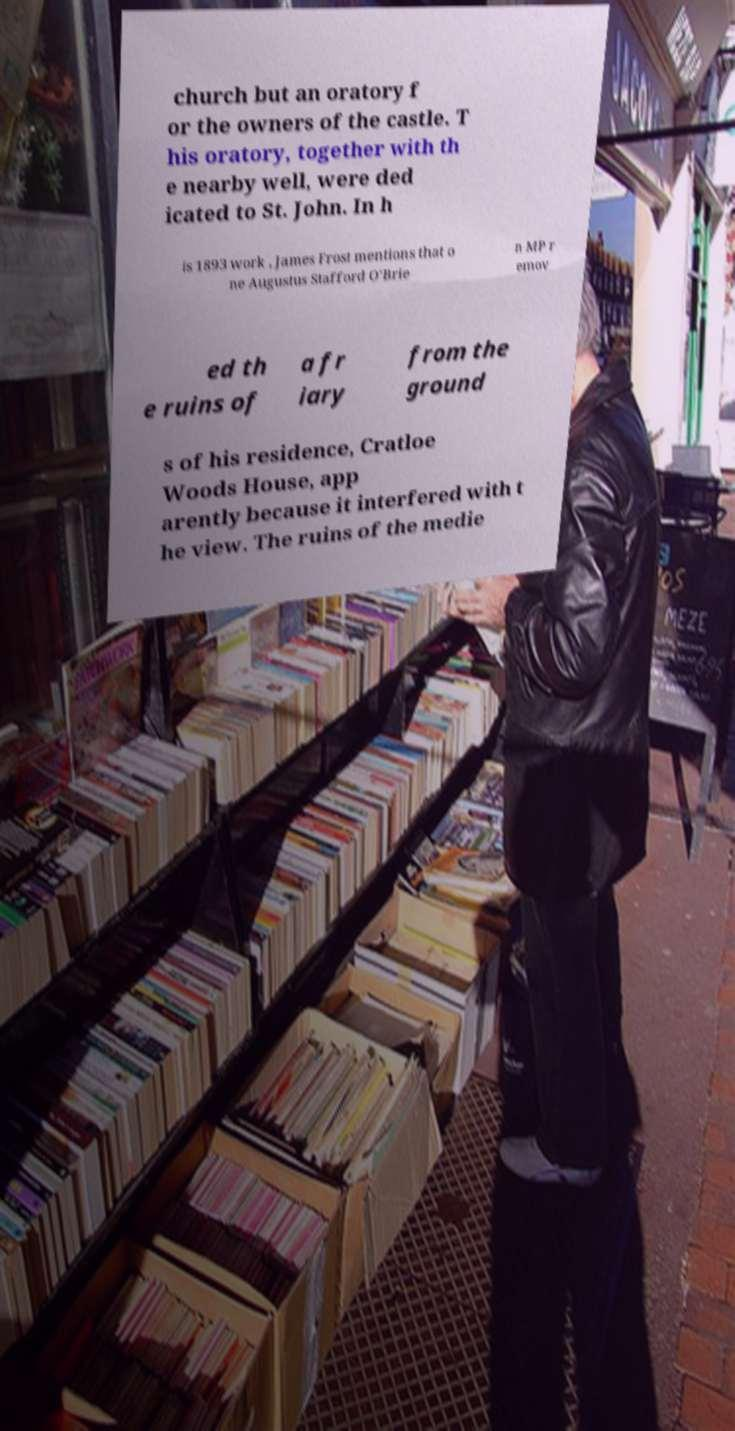Could you assist in decoding the text presented in this image and type it out clearly? church but an oratory f or the owners of the castle. T his oratory, together with th e nearby well, were ded icated to St. John. In h is 1893 work , James Frost mentions that o ne Augustus Stafford O'Brie n MP r emov ed th e ruins of a fr iary from the ground s of his residence, Cratloe Woods House, app arently because it interfered with t he view. The ruins of the medie 